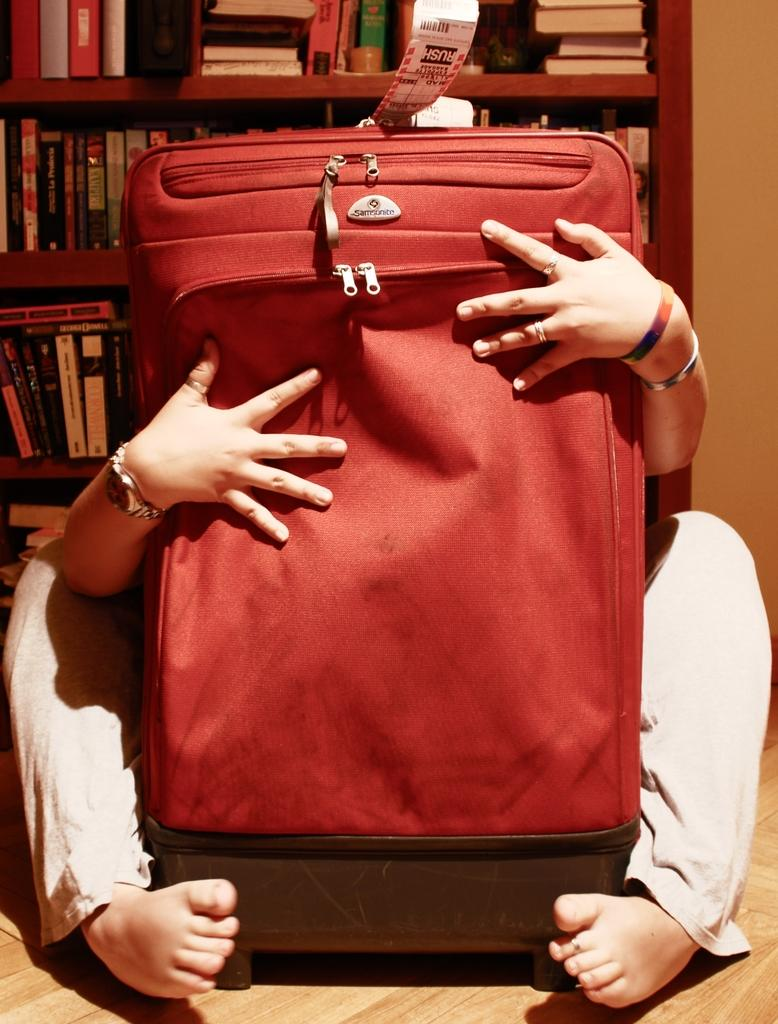What is the color of the bag in the middle of the image? The bag in the middle of the image is red. Who is holding the bag in the image? There is a person holding a bag in the image. What can be seen in the background of the image? There are items on a table in the background of the image. Can you describe the fight that is happening in the image? There is no fight depicted in the image; it only shows a person holding a red bag and items on a table in the background. 